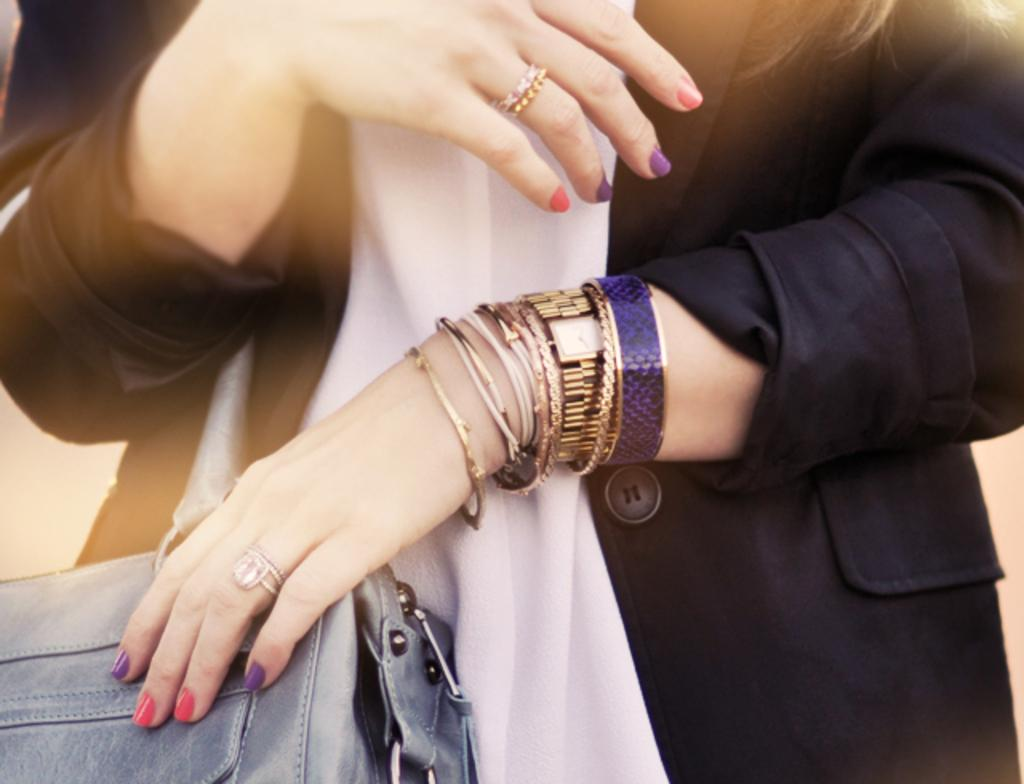Who or what is present in the image? There is a person in the image. What is the person wearing that is visible in the image? The person is wearing a bag and a black and white color dress. What types of accessories can be seen on the person in the image? There are bands, rings, and a watch visible in the image. What type of lace can be seen on the person's dress in the image? There is no lace visible on the person's dress in the image. What question is the person asking in the image? There is no indication in the image that the person is asking a question. 